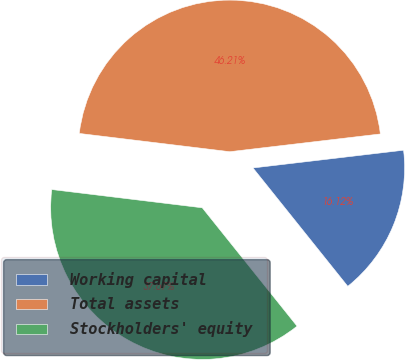Convert chart. <chart><loc_0><loc_0><loc_500><loc_500><pie_chart><fcel>Working capital<fcel>Total assets<fcel>Stockholders' equity<nl><fcel>16.12%<fcel>46.21%<fcel>37.67%<nl></chart> 